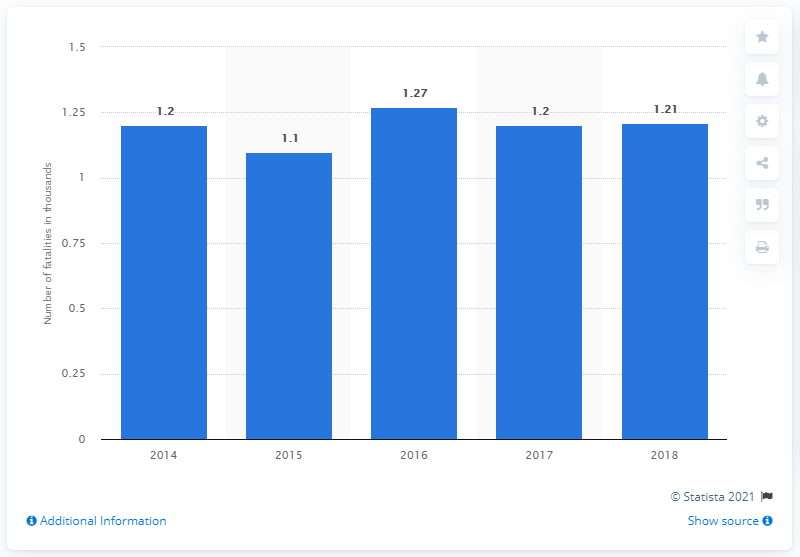Specify some key components in this picture. The missing data points are 1.2, 1.1, 1.2, and 1.21 from the chart. The chart contains the data point 1.27. To find the average of all blue bars, we need to add up all the values within the blue bars and divide by the number of blue bars. The result is 1.196... 